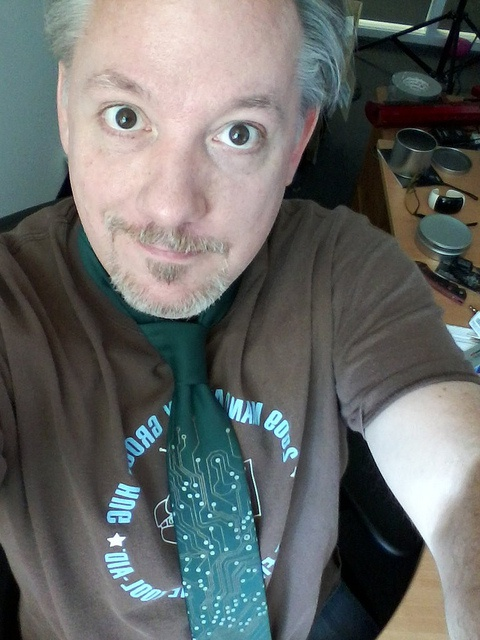Describe the objects in this image and their specific colors. I can see people in teal, gray, black, lightgray, and darkgray tones, tie in teal and black tones, chair in teal, black, gray, darkblue, and blue tones, and cup in teal, black, and gray tones in this image. 